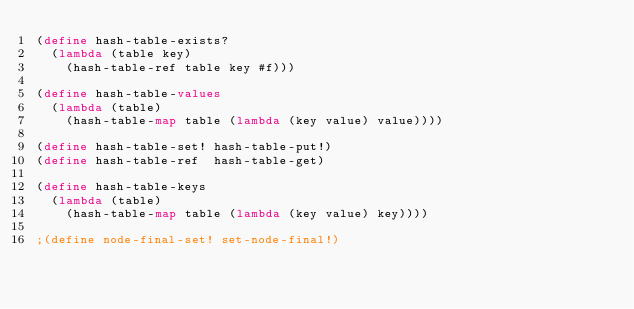<code> <loc_0><loc_0><loc_500><loc_500><_Scheme_>(define hash-table-exists? 
  (lambda (table key)
    (hash-table-ref table key #f))) 

(define hash-table-values
  (lambda (table)
    (hash-table-map table (lambda (key value) value))))

(define hash-table-set! hash-table-put!)
(define hash-table-ref  hash-table-get)

(define hash-table-keys
  (lambda (table)
    (hash-table-map table (lambda (key value) key))))

;(define node-final-set! set-node-final!)

</code> 